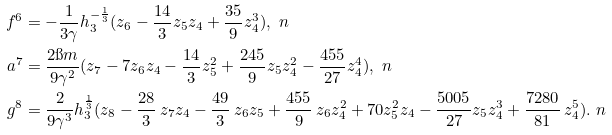Convert formula to latex. <formula><loc_0><loc_0><loc_500><loc_500>f ^ { 6 } & = - \frac { 1 } { 3 \gamma } h _ { 3 } ^ { - \frac { 1 } { 3 } } ( z _ { 6 } - \frac { 1 4 } { 3 } z _ { 5 } z _ { 4 } + \frac { 3 5 } { 9 } z _ { 4 } ^ { 3 } ) , \ n \\ a ^ { 7 } & = \frac { 2 \i m } { 9 \gamma ^ { 2 } } ( z _ { 7 } - 7 z _ { 6 } z _ { 4 } - \frac { 1 4 } { 3 } z _ { 5 } ^ { 2 } + \frac { 2 4 5 } { 9 } z _ { 5 } z _ { 4 } ^ { 2 } - \frac { 4 5 5 } { 2 7 } z _ { 4 } ^ { 4 } ) , \ n \\ g ^ { 8 } & = \frac { 2 } { 9 \gamma ^ { 3 } } h _ { 3 } ^ { \frac { 1 } { 3 } } ( z _ { 8 } - { \frac { 2 8 } { 3 } } \, z _ { 7 } z _ { 4 } - { \frac { 4 9 } { 3 } } \, z _ { 6 } z _ { 5 } + { \frac { 4 5 5 } { 9 } } \, z _ { 6 } z _ { 4 } ^ { 2 } + 7 0 z _ { 5 } ^ { 2 } z _ { 4 } - { \frac { 5 0 0 5 } { 2 7 } } z _ { 5 } z _ { 4 } ^ { 3 } + { \frac { 7 2 8 0 } { 8 1 } } \, z _ { 4 } ^ { 5 } ) . \ n</formula> 